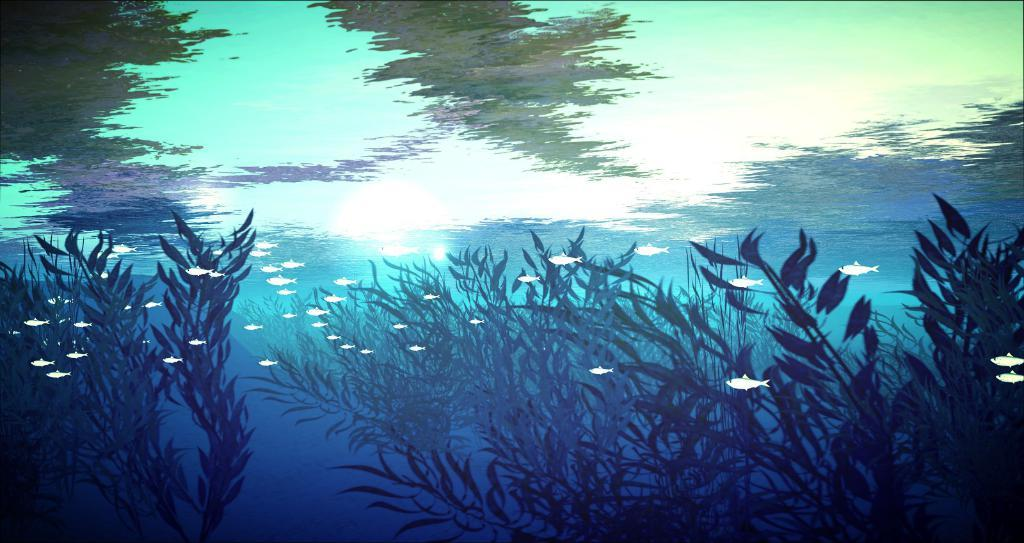What type of artwork is depicted in the image? The image is a painting. What can be seen at the bottom of the painting? There are plants at the bottom of the painting. What creatures are visible in the water within the painting? There are fishes visible in the water within the painting. Can you see a shoe being sold at the market in the painting? There is no shoe or market present in the painting; it features plants and fishes in water. 